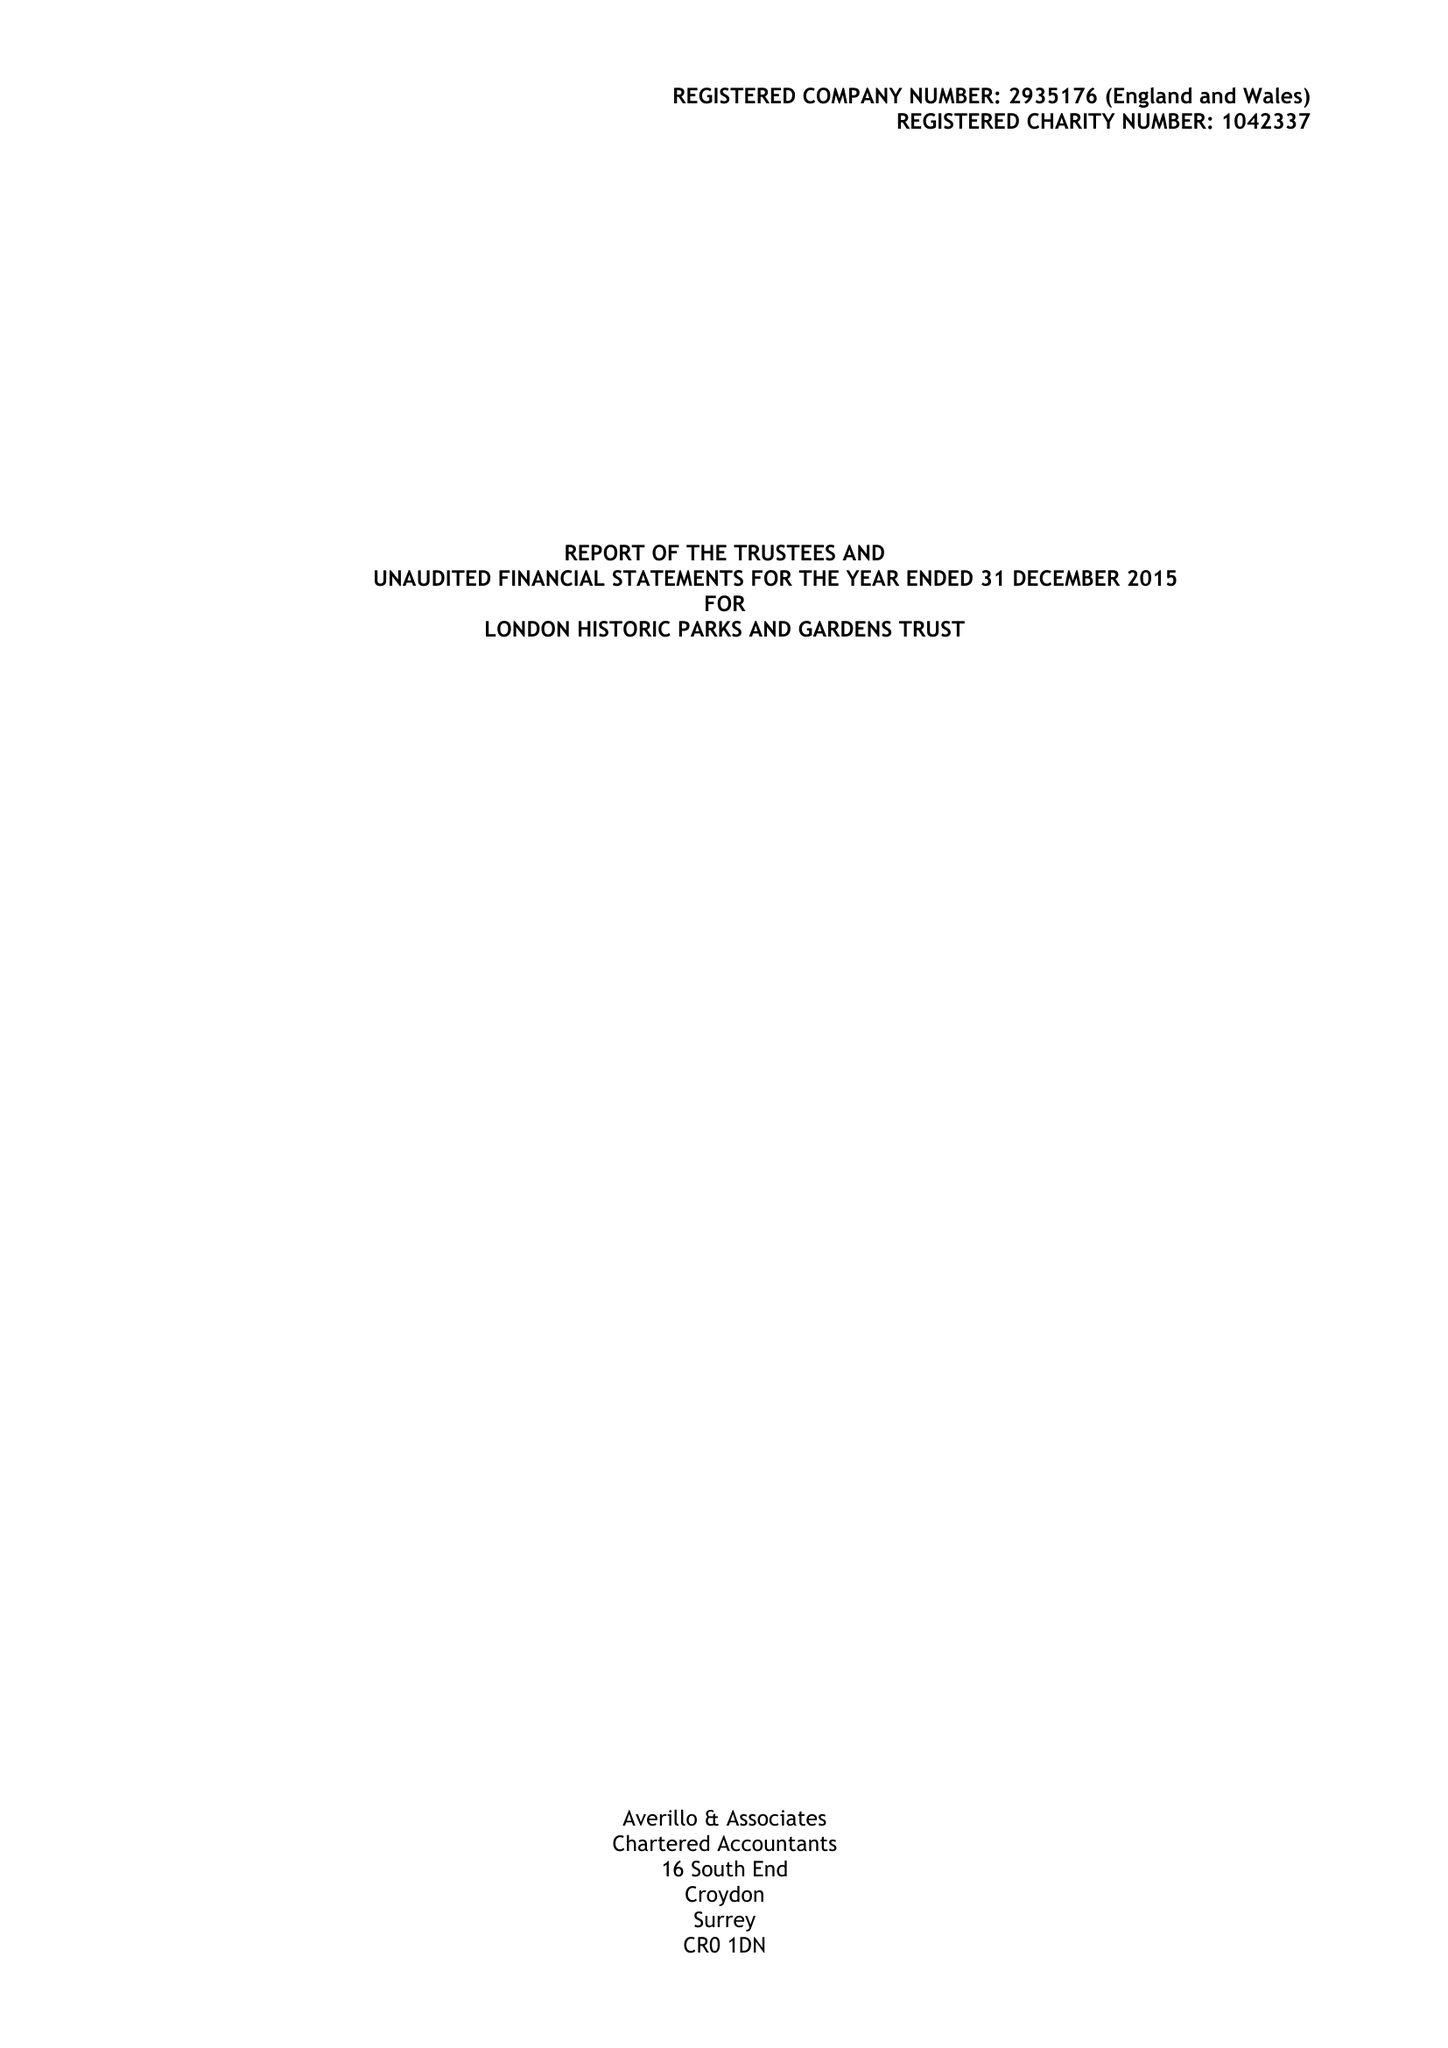What is the value for the charity_number?
Answer the question using a single word or phrase. 1042337 